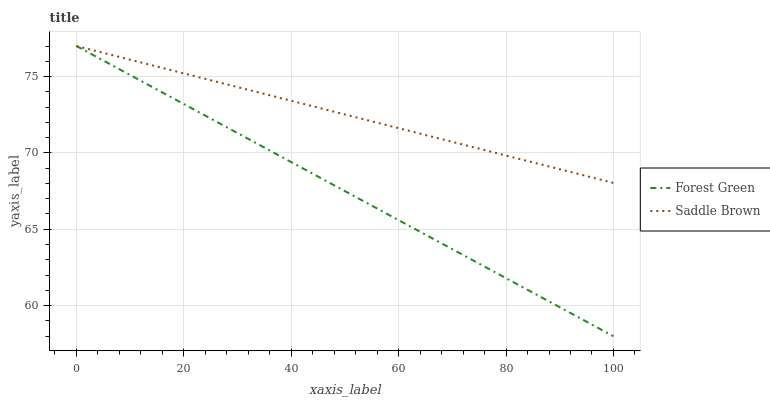Does Forest Green have the minimum area under the curve?
Answer yes or no. Yes. Does Saddle Brown have the maximum area under the curve?
Answer yes or no. Yes. Does Saddle Brown have the minimum area under the curve?
Answer yes or no. No. Is Forest Green the smoothest?
Answer yes or no. Yes. Is Saddle Brown the roughest?
Answer yes or no. Yes. Is Saddle Brown the smoothest?
Answer yes or no. No. Does Forest Green have the lowest value?
Answer yes or no. Yes. Does Saddle Brown have the lowest value?
Answer yes or no. No. Does Saddle Brown have the highest value?
Answer yes or no. Yes. Does Saddle Brown intersect Forest Green?
Answer yes or no. Yes. Is Saddle Brown less than Forest Green?
Answer yes or no. No. Is Saddle Brown greater than Forest Green?
Answer yes or no. No. 